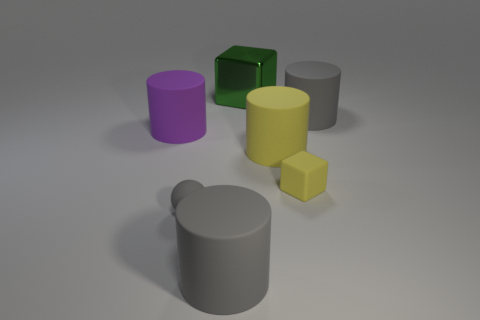Subtract 1 cylinders. How many cylinders are left? 3 Subtract all brown cylinders. Subtract all red blocks. How many cylinders are left? 4 Add 2 large gray objects. How many objects exist? 9 Subtract all cylinders. How many objects are left? 3 Add 4 big matte cylinders. How many big matte cylinders exist? 8 Subtract 0 red cylinders. How many objects are left? 7 Subtract all big metal things. Subtract all large blue cylinders. How many objects are left? 6 Add 5 tiny yellow matte objects. How many tiny yellow matte objects are left? 6 